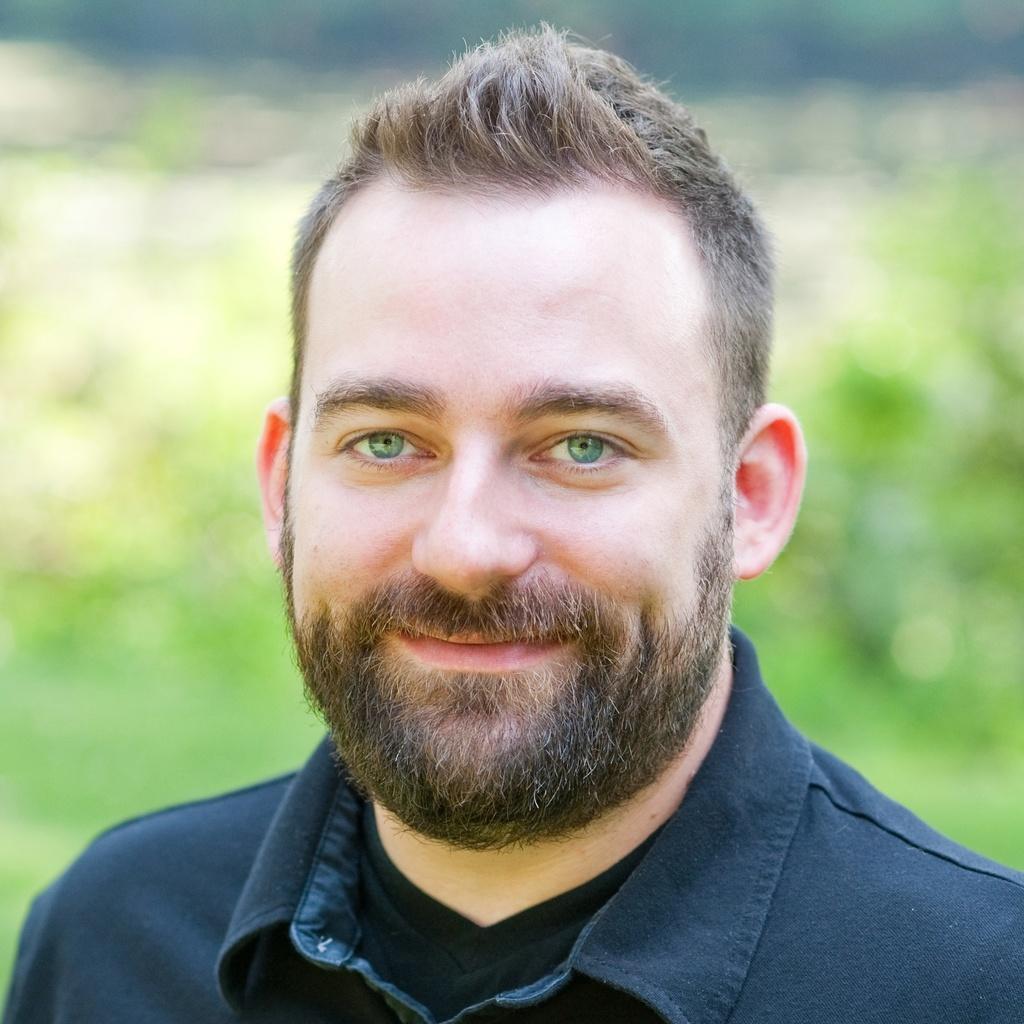Please provide a concise description of this image. In this picture I see there is a man, he is wearing a blue shirt and he is smiling, he has mustache and beard. The backdrop is blurred. 